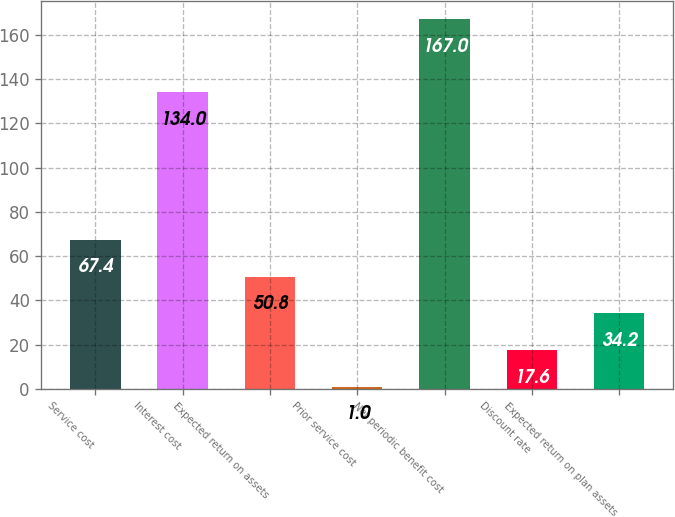Convert chart. <chart><loc_0><loc_0><loc_500><loc_500><bar_chart><fcel>Service cost<fcel>Interest cost<fcel>Expected return on assets<fcel>Prior service cost<fcel>Net periodic benefit cost<fcel>Discount rate<fcel>Expected return on plan assets<nl><fcel>67.4<fcel>134<fcel>50.8<fcel>1<fcel>167<fcel>17.6<fcel>34.2<nl></chart> 